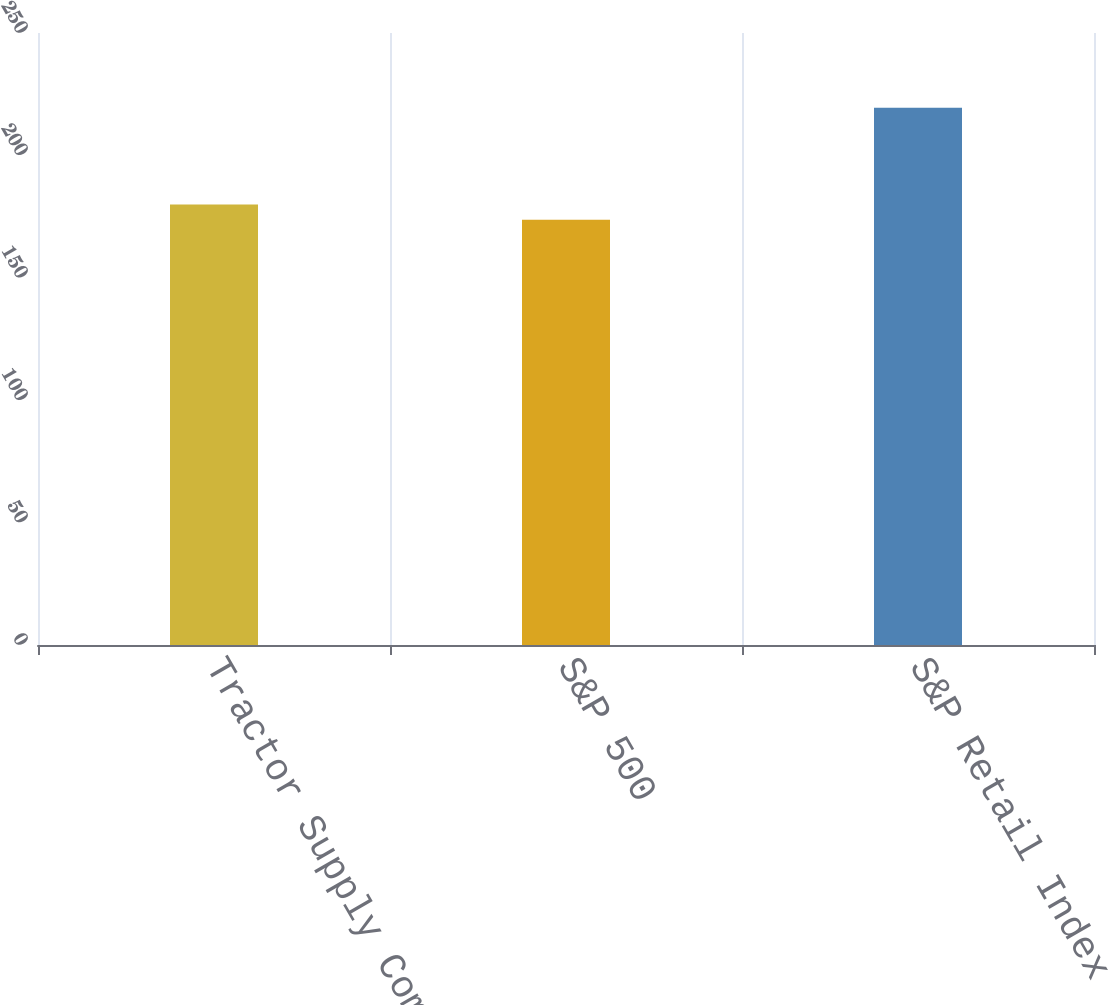Convert chart. <chart><loc_0><loc_0><loc_500><loc_500><bar_chart><fcel>Tractor Supply Company<fcel>S&P 500<fcel>S&P Retail Index<nl><fcel>179.94<fcel>173.74<fcel>219.43<nl></chart> 